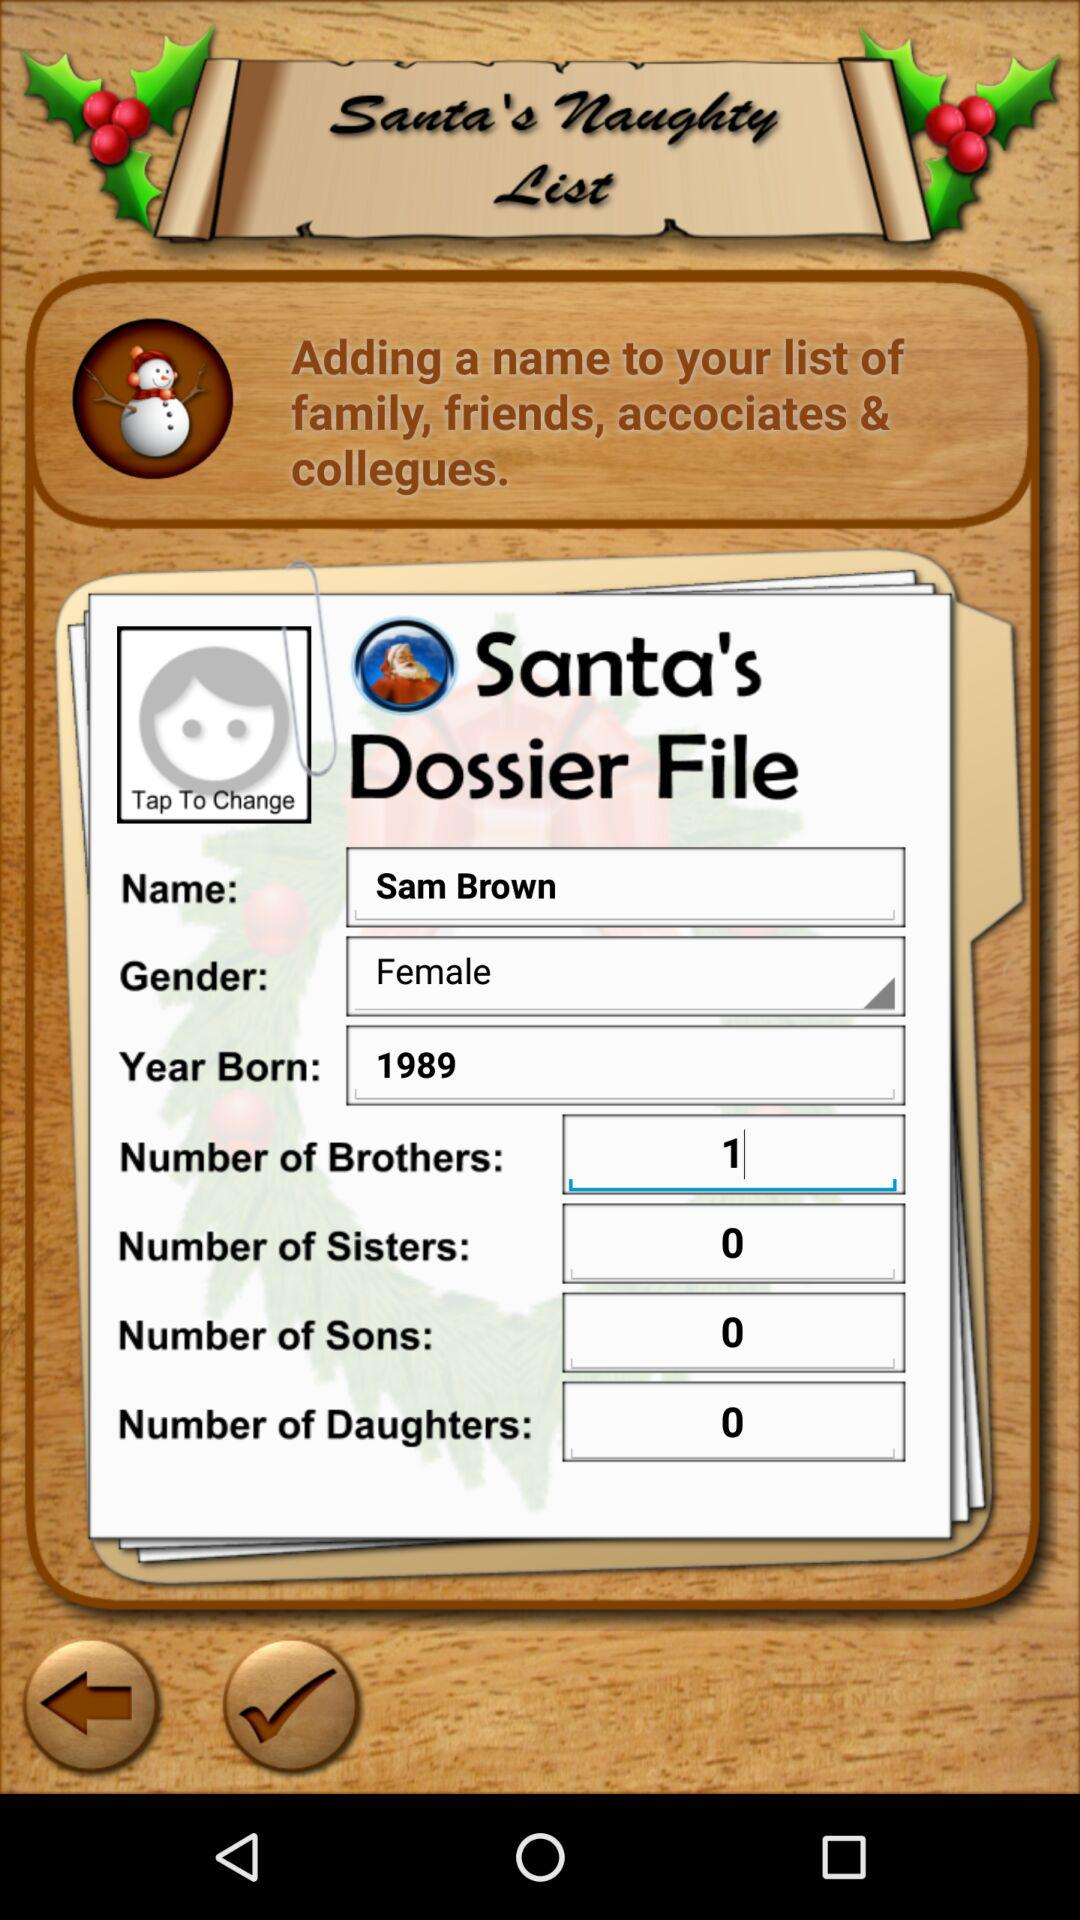What is the gender of the user? The gender of the user is female. 